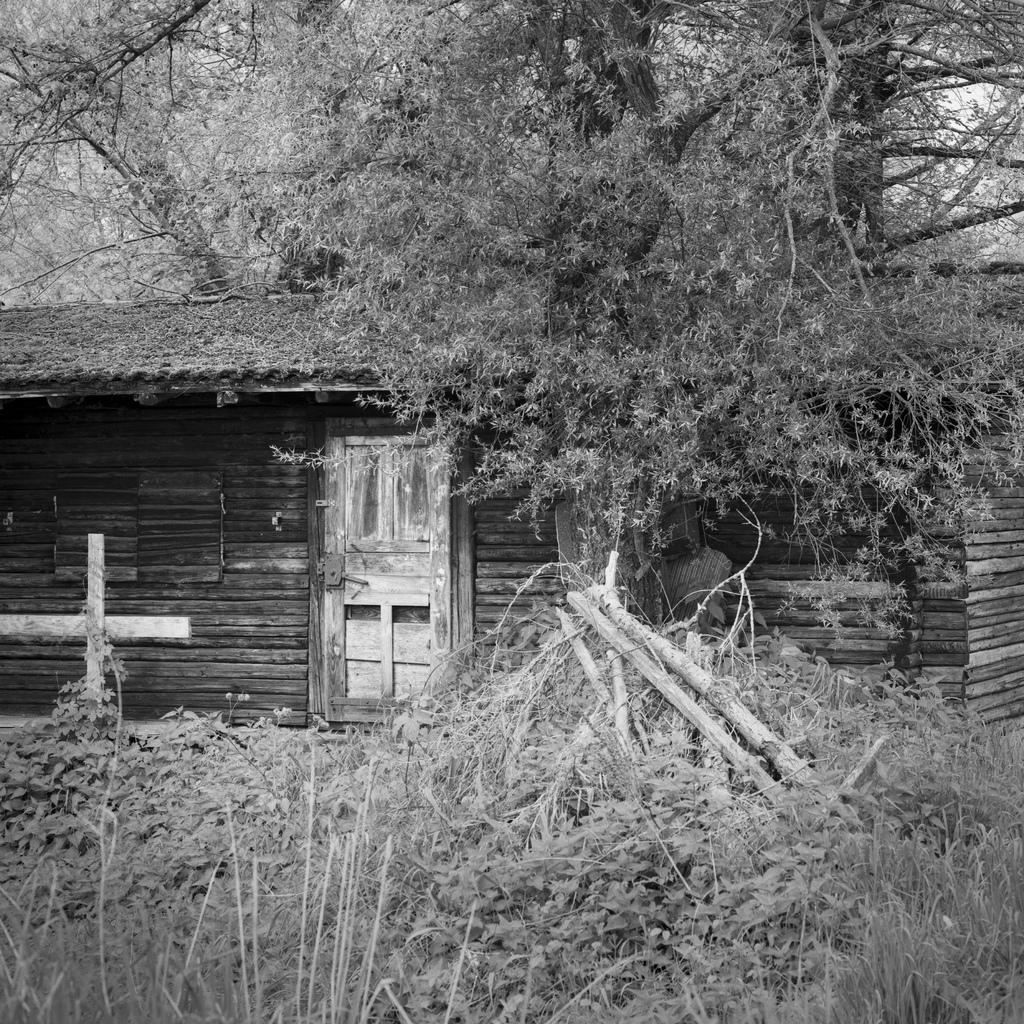What is the color scheme of the image? The image is black and white. What type of vegetation can be seen in the image? There are plants and trees in the image. What type of structure is present in the image? There is a hut in the image. What feature of the hut is visible in the image? There is a door in the image. How does the ink affect the plants in the image? There is no ink present in the image, so it cannot affect the plants. 